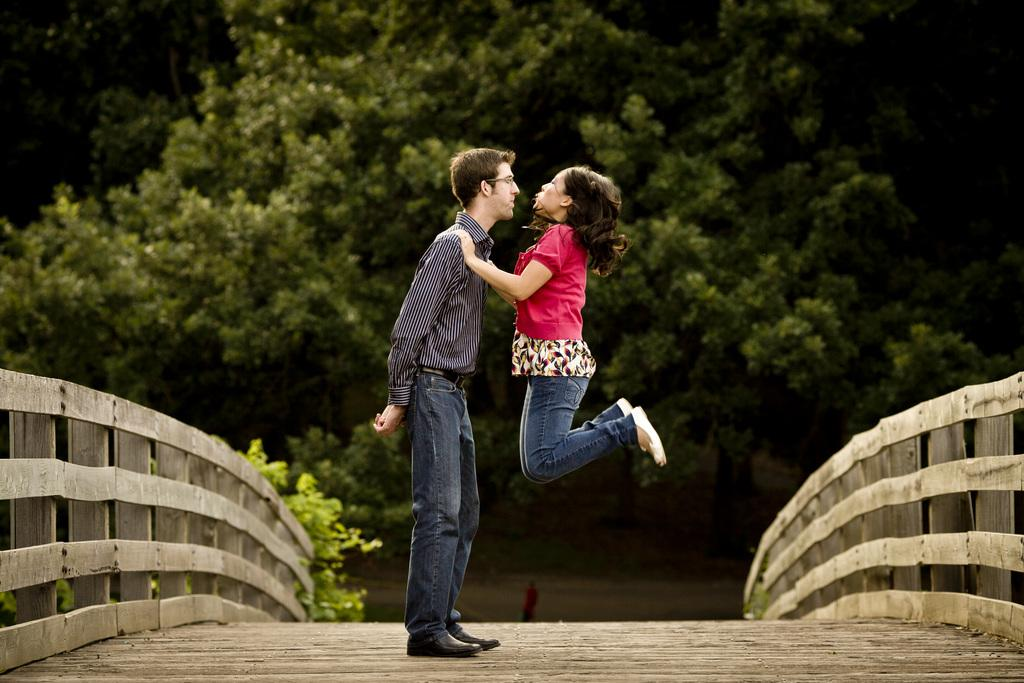How many people are in the image? There are two people in the middle of the image. What is located on the right side of the image? There are wooden railings on the right side of the image. What is located on the left side of the image? There are wooden railings on the left side of the image. What can be seen in the background of the image? There are trees visible in the background of the image. What type of appliance can be seen in the image? There is no appliance present in the image. What color is the nose of the person on the left side of the image? There is no person on the left side of the image, and even if there were, we cannot determine the color of their nose from the provided facts. 